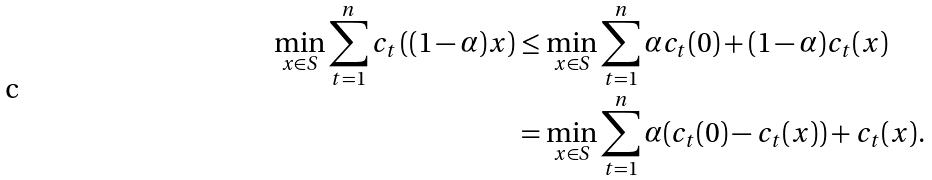Convert formula to latex. <formula><loc_0><loc_0><loc_500><loc_500>\min _ { x \in S } \sum _ { t = 1 } ^ { n } c _ { t } \left ( ( 1 - \alpha ) x \right ) & \leq \min _ { x \in S } \sum _ { t = 1 } ^ { n } \alpha c _ { t } ( 0 ) + ( 1 - \alpha ) c _ { t } ( x ) \\ & = \min _ { x \in S } \sum _ { t = 1 } ^ { n } \alpha ( c _ { t } ( 0 ) - c _ { t } ( x ) ) + c _ { t } ( x ) .</formula> 